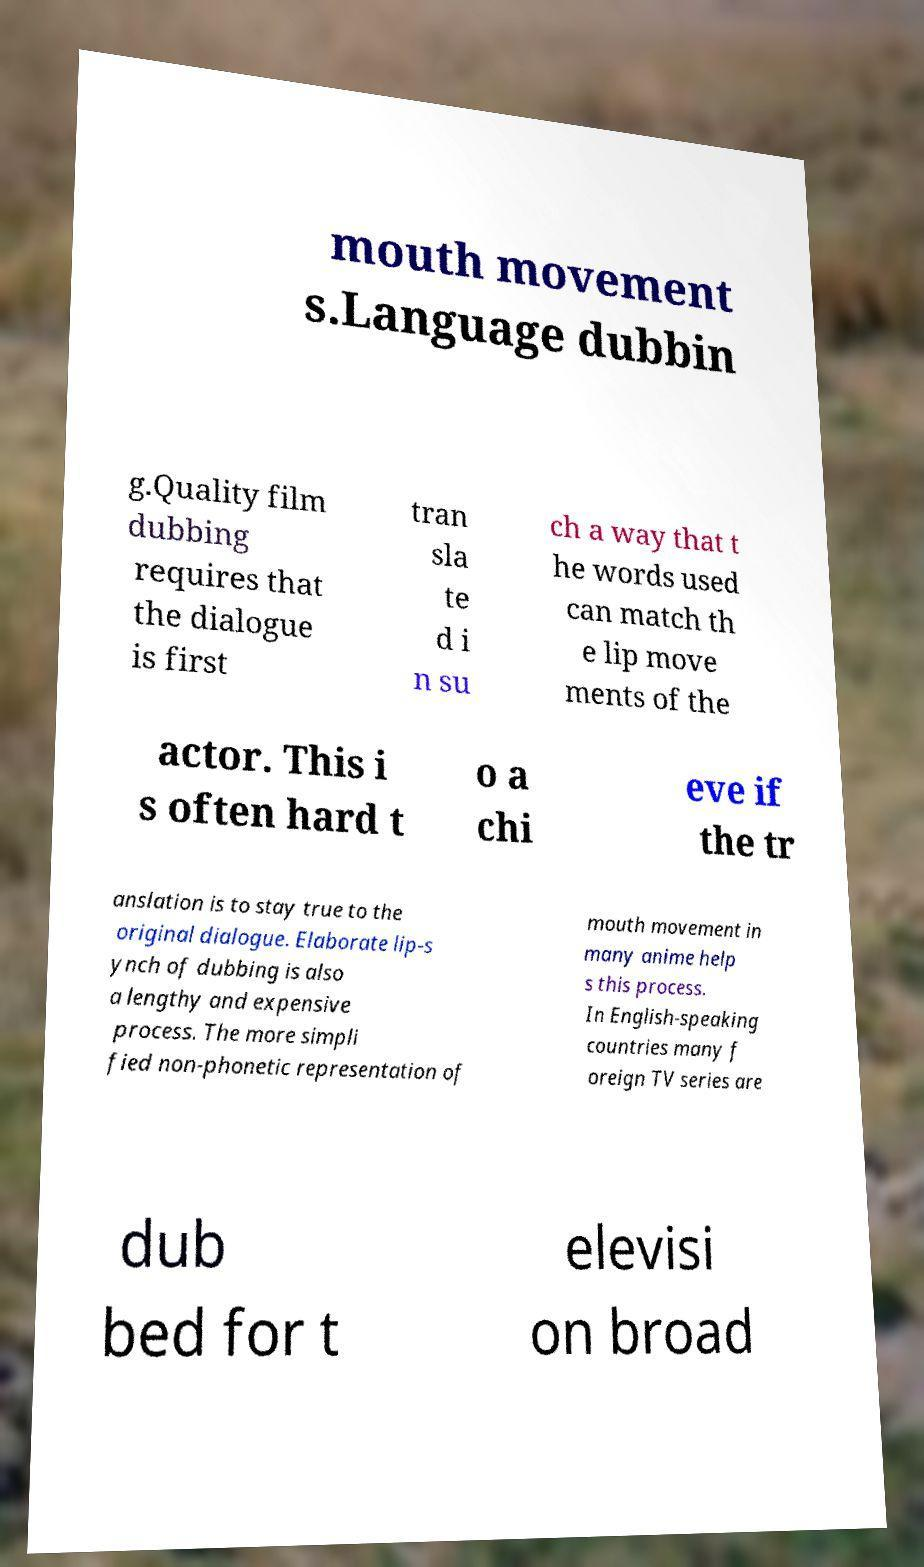For documentation purposes, I need the text within this image transcribed. Could you provide that? mouth movement s.Language dubbin g.Quality film dubbing requires that the dialogue is first tran sla te d i n su ch a way that t he words used can match th e lip move ments of the actor. This i s often hard t o a chi eve if the tr anslation is to stay true to the original dialogue. Elaborate lip-s ynch of dubbing is also a lengthy and expensive process. The more simpli fied non-phonetic representation of mouth movement in many anime help s this process. In English-speaking countries many f oreign TV series are dub bed for t elevisi on broad 